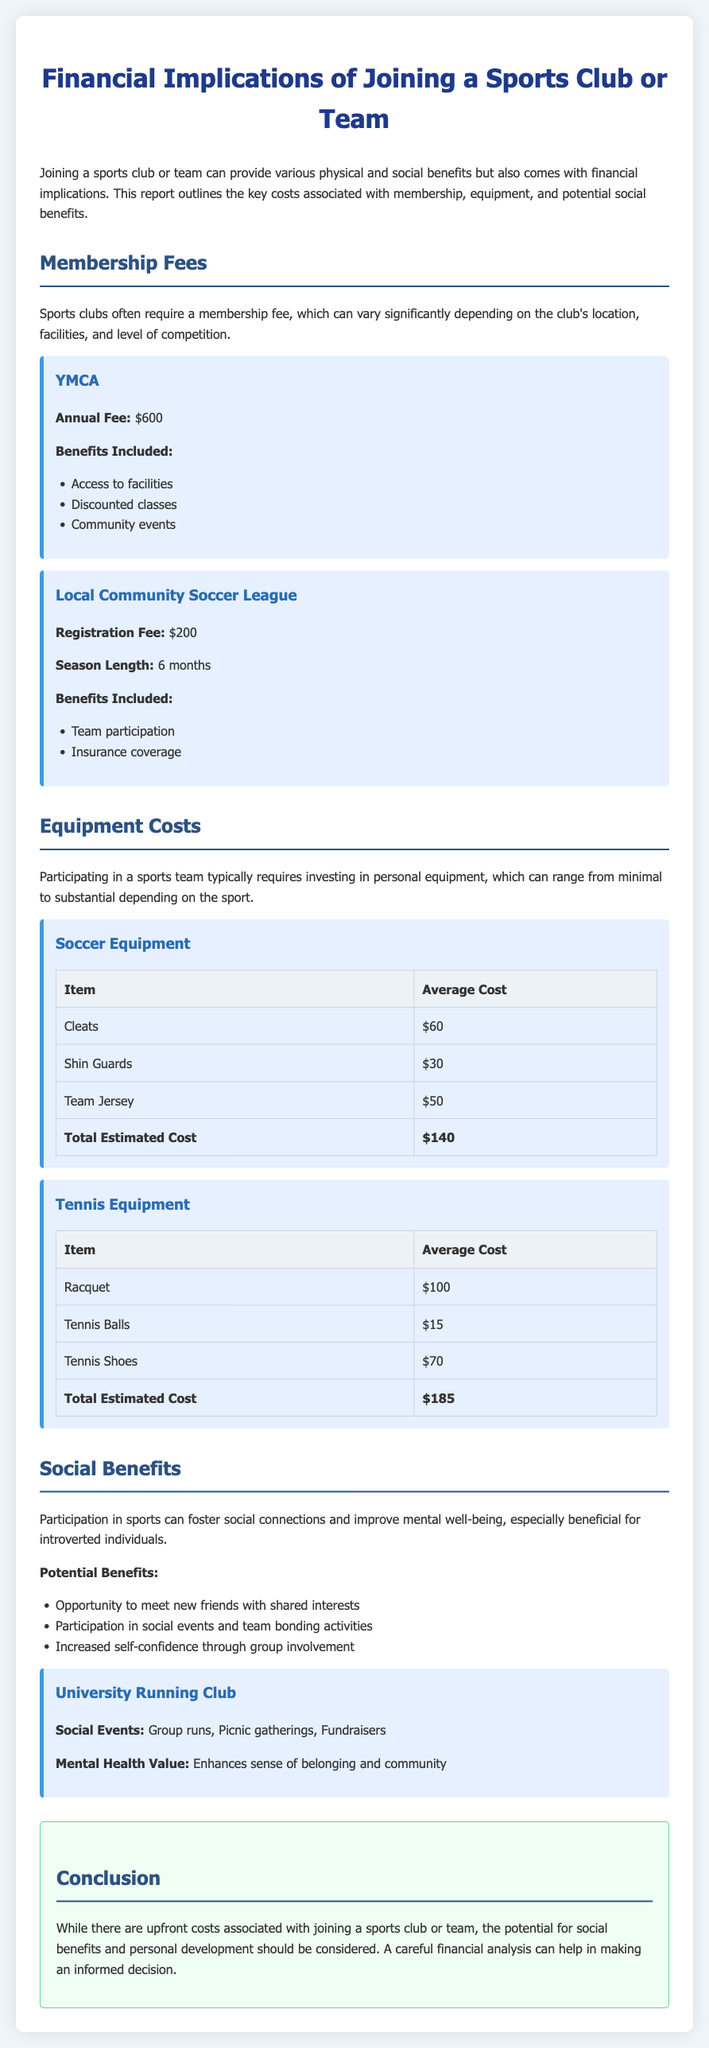What is the annual fee for YMCA? The annual fee for YMCA is specified in the membership fees section as $600.
Answer: $600 What is the registration fee for the Local Community Soccer League? The registration fee mentioned for the Local Community Soccer League is $200.
Answer: $200 What is the total estimated cost of soccer equipment? The total estimated cost of soccer equipment listed in the document is $140.
Answer: $140 Which item costs the most in tennis equipment? The item that costs the most in tennis equipment is the racquet, which is listed as $100.
Answer: Racquet What are two benefits included with a YMCA membership? The benefits included with a YMCA membership include access to facilities and discounted classes, as illustrated in the report.
Answer: Access to facilities, Discounted classes What social events are associated with the University Running Club? The social events associated with the University Running Club include group runs, picnic gatherings, and fundraisers.
Answer: Group runs, Picnic gatherings, Fundraisers How long is the season for the Local Community Soccer League? The season length for the Local Community Soccer League is explicitly described as 6 months long.
Answer: 6 months What can participation in sports improve, especially for introverted individuals? The participation in sports can improve mental well-being, as noted in the social benefits section for introverted individuals.
Answer: Mental well-being What is the focus of the conclusion in the report? The conclusion of the report emphasizes considering social benefits and personal development along with the costs involved in joining a sports club or team.
Answer: Social benefits, Personal development 